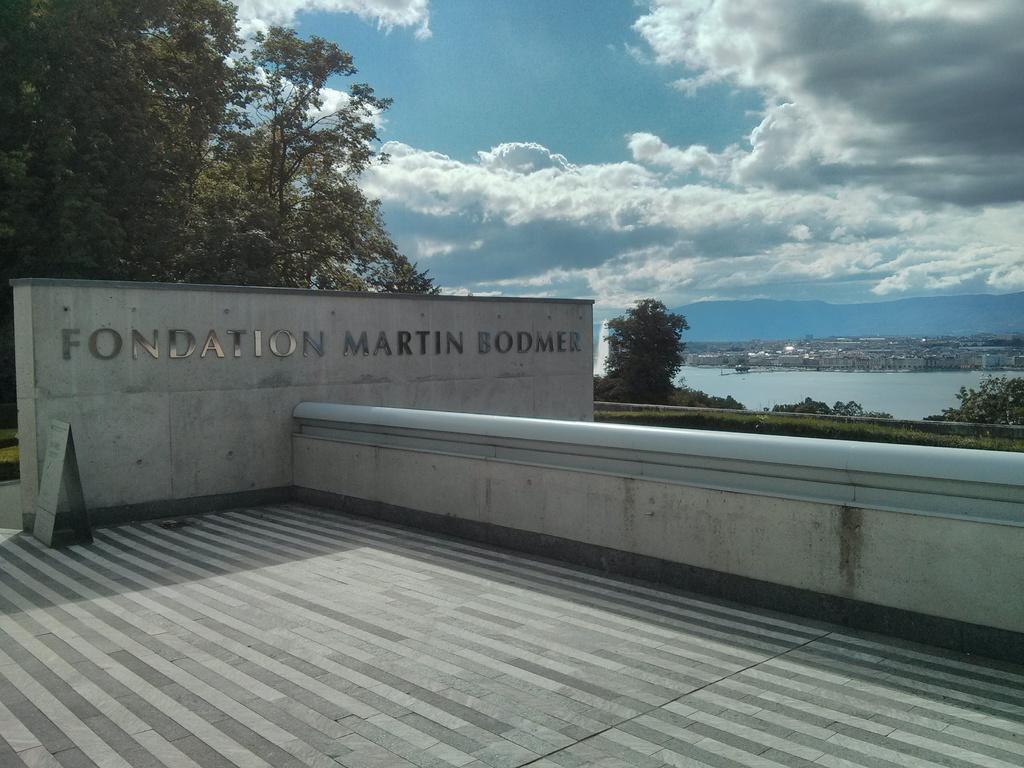Can you describe this image briefly? In the image we can see a wall, on the wall there is a text. These are the trees, water and a cloudy sky, this is a floor. 